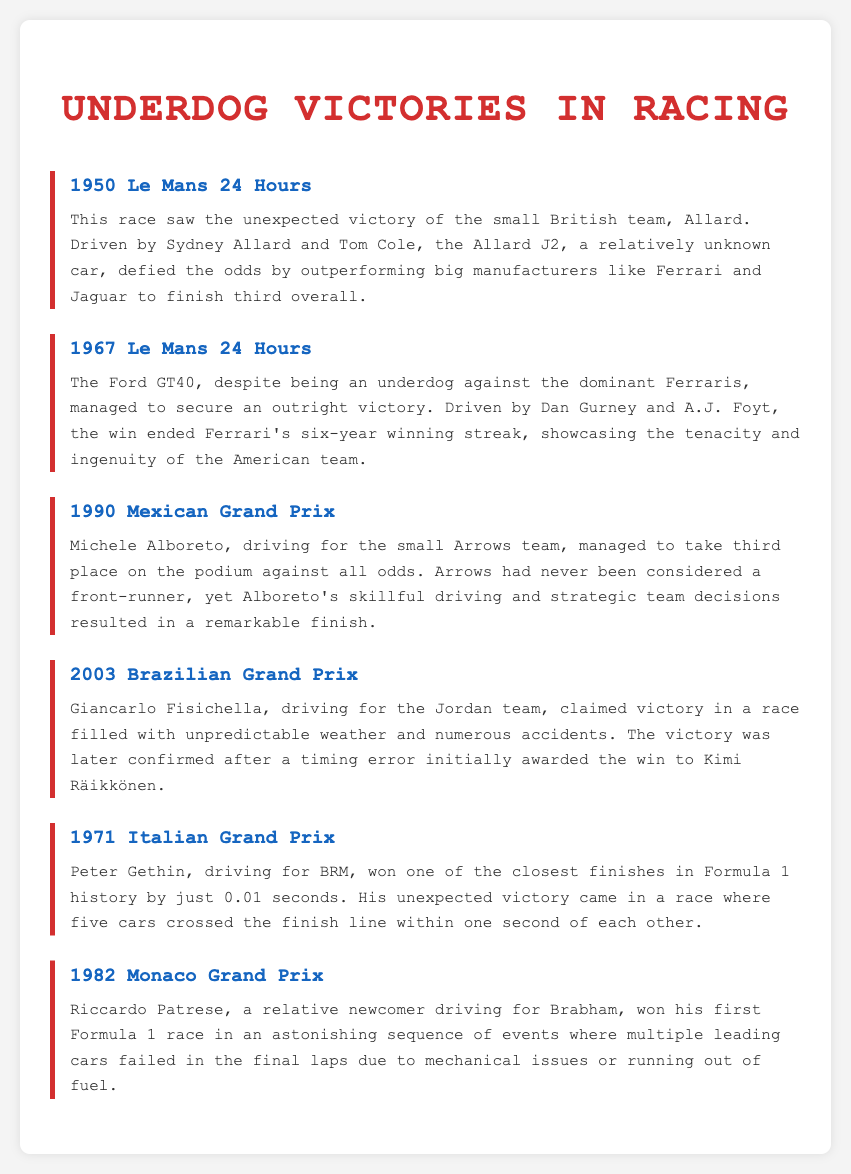What year did the 1950 Le Mans 24 Hours take place? The document states that the 1950 Le Mans 24 Hours is noted for the unexpected victory of the Allard team.
Answer: 1950 Who drove the Ford GT40 in the 1967 Le Mans 24 Hours? The document mentions that the Ford GT40 was driven by Dan Gurney and A.J. Foyt during the 1967 Le Mans.
Answer: Dan Gurney and A.J. Foyt Which team was Michele Alboreto driving for in the 1990 Mexican Grand Prix? The document indicates that Alboreto was driving for the small Arrows team in the 1990 Mexican Grand Prix.
Answer: Arrows What was notable about Peter Gethin's victory in the 1971 Italian Grand Prix? The document highlights that he won by just 0.01 seconds, marking one of the closest finishes in Formula 1 history.
Answer: 0.01 seconds In what condition did Giancarlo Fisichella claim victory in the 2003 Brazilian Grand Prix? The document notes that the race was filled with unpredictable weather and numerous accidents.
Answer: Unpredictable weather and numerous accidents How many leading cars failed in the final laps of the 1982 Monaco Grand Prix? The document implies that multiple leading cars experienced failures, though it doesn't specify a number.
Answer: Multiple 